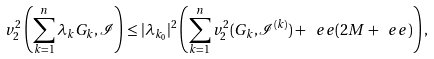<formula> <loc_0><loc_0><loc_500><loc_500>v _ { 2 } ^ { 2 } \left ( \sum _ { k = 1 } ^ { n } \lambda _ { k } G _ { k } , \mathcal { I } \right ) \leq | \lambda _ { k _ { 0 } } | ^ { 2 } \left ( \sum _ { k = 1 } ^ { n } v _ { 2 } ^ { 2 } ( G _ { k } , \mathcal { I } ^ { ( k ) } ) + \ e e ( 2 M + \ e e ) \right ) ,</formula> 